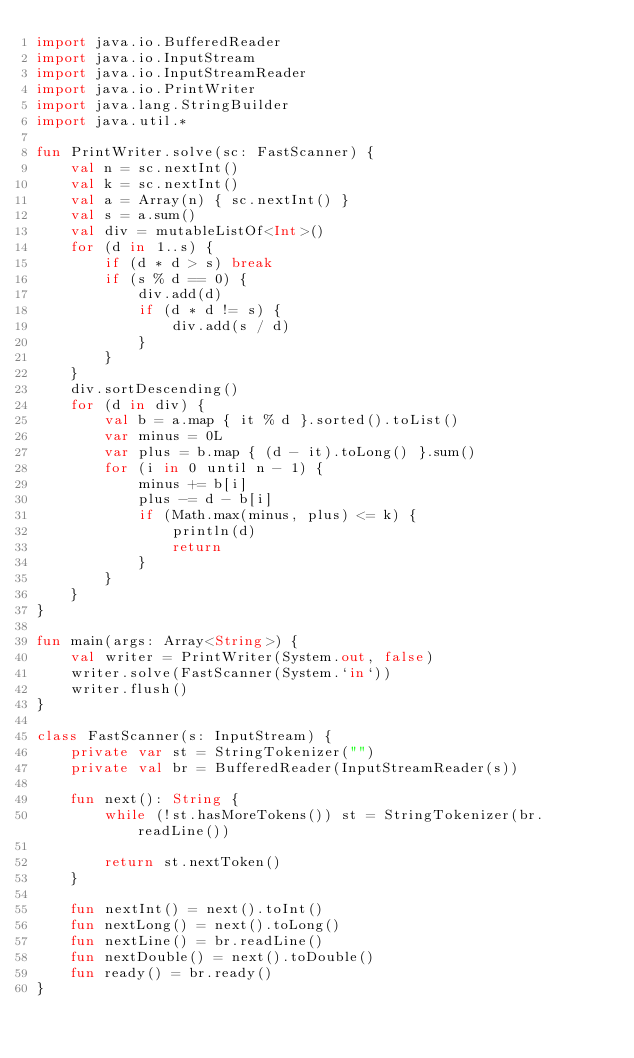Convert code to text. <code><loc_0><loc_0><loc_500><loc_500><_Kotlin_>import java.io.BufferedReader
import java.io.InputStream
import java.io.InputStreamReader
import java.io.PrintWriter
import java.lang.StringBuilder
import java.util.*

fun PrintWriter.solve(sc: FastScanner) {
    val n = sc.nextInt()
    val k = sc.nextInt()
    val a = Array(n) { sc.nextInt() }
    val s = a.sum()
    val div = mutableListOf<Int>()
    for (d in 1..s) {
        if (d * d > s) break
        if (s % d == 0) {
            div.add(d)
            if (d * d != s) {
                div.add(s / d)
            }
        }
    }
    div.sortDescending()
    for (d in div) {
        val b = a.map { it % d }.sorted().toList()
        var minus = 0L
        var plus = b.map { (d - it).toLong() }.sum()
        for (i in 0 until n - 1) {
            minus += b[i]
            plus -= d - b[i]
            if (Math.max(minus, plus) <= k) {
                println(d)
                return
            }
        }
    }
}

fun main(args: Array<String>) {
    val writer = PrintWriter(System.out, false)
    writer.solve(FastScanner(System.`in`))
    writer.flush()
}

class FastScanner(s: InputStream) {
    private var st = StringTokenizer("")
    private val br = BufferedReader(InputStreamReader(s))

    fun next(): String {
        while (!st.hasMoreTokens()) st = StringTokenizer(br.readLine())

        return st.nextToken()
    }

    fun nextInt() = next().toInt()
    fun nextLong() = next().toLong()
    fun nextLine() = br.readLine()
    fun nextDouble() = next().toDouble()
    fun ready() = br.ready()
}
</code> 